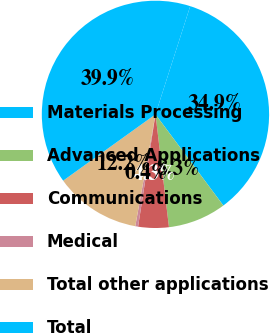<chart> <loc_0><loc_0><loc_500><loc_500><pie_chart><fcel>Materials Processing<fcel>Advanced Applications<fcel>Communications<fcel>Medical<fcel>Total other applications<fcel>Total<nl><fcel>34.87%<fcel>8.29%<fcel>4.34%<fcel>0.4%<fcel>12.24%<fcel>39.86%<nl></chart> 